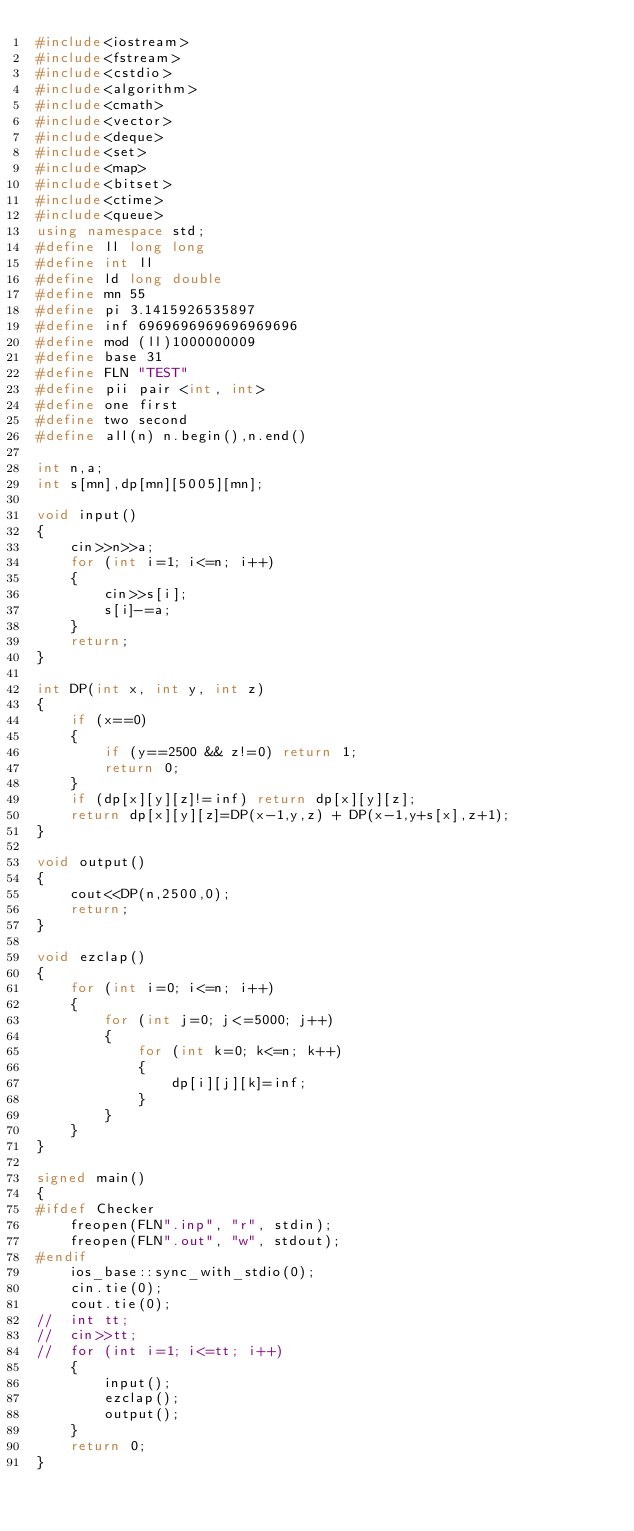Convert code to text. <code><loc_0><loc_0><loc_500><loc_500><_C++_>#include<iostream>
#include<fstream>
#include<cstdio>
#include<algorithm>
#include<cmath>
#include<vector>
#include<deque>
#include<set>
#include<map>
#include<bitset>
#include<ctime>
#include<queue>
using namespace std;
#define ll long long
#define int ll
#define ld long double
#define mn 55
#define pi 3.1415926535897
#define inf 6969696969696969696
#define mod (ll)1000000009
#define base 31
#define FLN "TEST"
#define pii pair <int, int>
#define one first
#define two second
#define all(n) n.begin(),n.end()

int n,a;
int s[mn],dp[mn][5005][mn];

void input()
{
	cin>>n>>a;
	for (int i=1; i<=n; i++)
	{
		cin>>s[i];
		s[i]-=a;
	}
	return;
}

int DP(int x, int y, int z)
{
	if (x==0)
	{
		if (y==2500 && z!=0) return 1;
		return 0;
	}
	if (dp[x][y][z]!=inf) return dp[x][y][z];
	return dp[x][y][z]=DP(x-1,y,z) + DP(x-1,y+s[x],z+1); 
}

void output()
{
	cout<<DP(n,2500,0);
	return;
}

void ezclap()
{
	for (int i=0; i<=n; i++)
	{
		for (int j=0; j<=5000; j++)
		{
			for (int k=0; k<=n; k++)
			{
				dp[i][j][k]=inf;
			}
		}
	}
}

signed main()
{
#ifdef Checker
	freopen(FLN".inp", "r", stdin);
	freopen(FLN".out", "w", stdout);
#endif
	ios_base::sync_with_stdio(0);
	cin.tie(0);
	cout.tie(0);
//	int tt;
//	cin>>tt;
//	for (int i=1; i<=tt; i++)
	{
		input();
		ezclap();
		output();
	}
	return 0;
}

</code> 